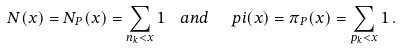<formula> <loc_0><loc_0><loc_500><loc_500>N ( x ) = N _ { P } ( x ) = \sum _ { n _ { k } < x } 1 \ \ a n d \ \ \ p i ( x ) = \pi _ { P } ( x ) = \sum _ { p _ { k } < x } 1 \, .</formula> 